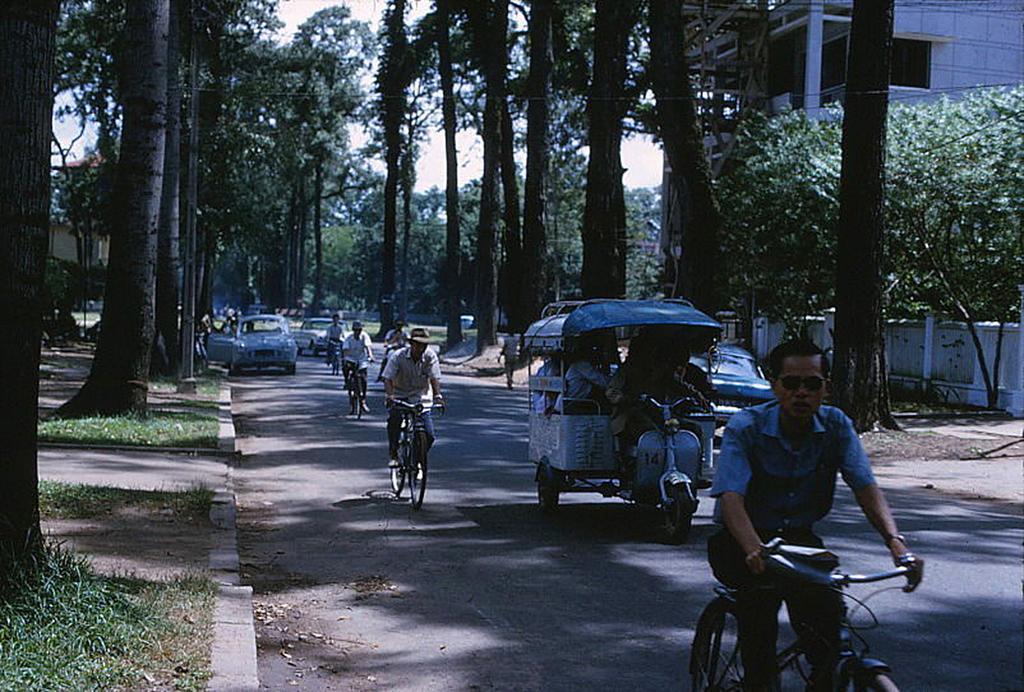How would you summarize this image in a sentence or two? In this image we can see two buildings, one wall, one man walking, one man standing, some men riding bicycles, some vehicles on the road, some people sitting in the vehicle, one person driving the vehicle, some objects on the ground, some dried trees, some trees, bushes, plants and grass on the ground. At the top there is the sky and the background is blurred. 